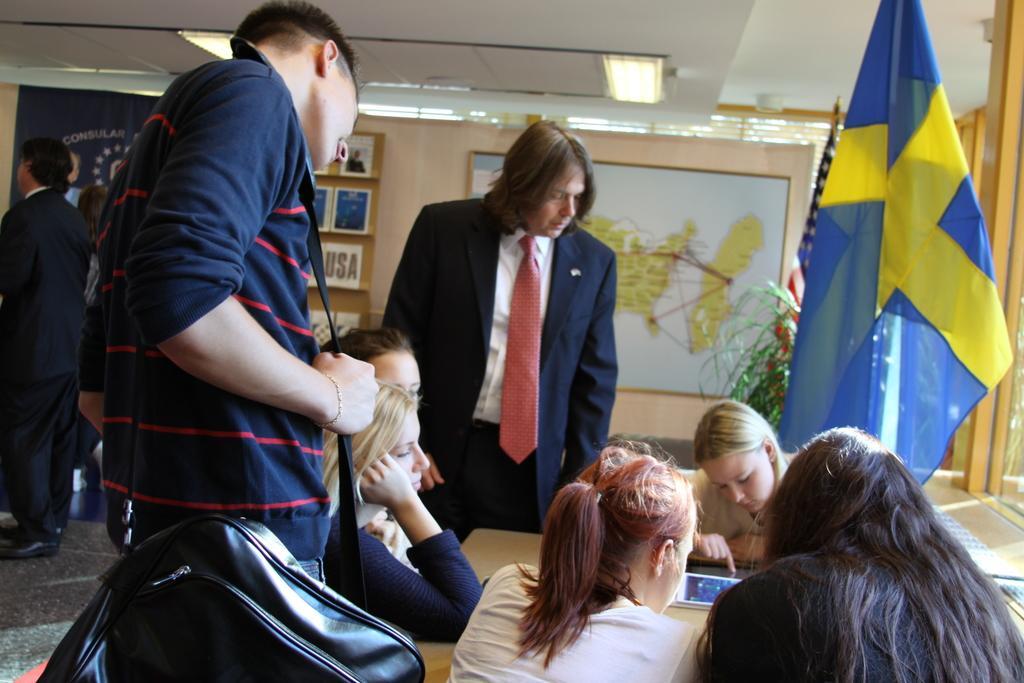Can you describe this image briefly? In this image we can see group of women sitting in front of a table, a group of persons is standing one person is carrying a bag. In the background, we can see two flags on poles, a plant, photo frames on the wall and some lights. 